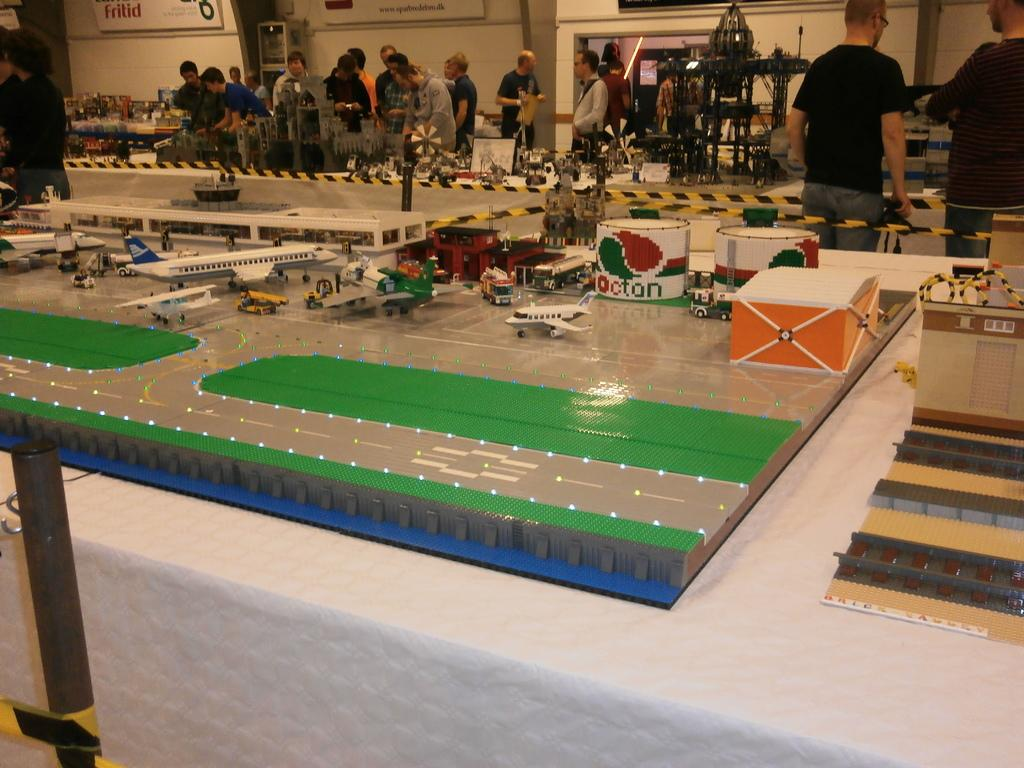What can be seen in the image involving people? There are people standing in the image. What are the people wearing? The people are wearing clothes. What type of toys are present in the image? There are toys of flying jets in the image. What objects can be seen in the image that are used for storage? There are boxes in the image. What safety measure is visible in the image? There is yellow tape in the image. What vertical structure is present in the image? There is a pole in the image. What type of printed material is visible in the image? There is a poster in the image. What type of architectural feature is present in the image? There is a wall in the image. What type of carriage is being used to transport the sleet in the image? There is no carriage or sleet present in the image. What adjustment needs to be made to the pole in the image? There is no indication in the image that any adjustment needs to be made to the pole. 